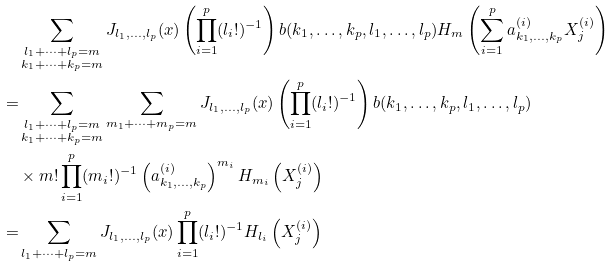<formula> <loc_0><loc_0><loc_500><loc_500>& \sum _ { \substack { l _ { 1 } + \dots + l _ { p } = m \\ k _ { 1 } + \dots + k _ { p } = m } } J _ { l _ { 1 } , \dots , l _ { p } } ( x ) \left ( \prod _ { i = 1 } ^ { p } ( l _ { i } ! ) ^ { - 1 } \right ) b ( k _ { 1 } , \dots , k _ { p } , l _ { 1 } , \dots , l _ { p } ) H _ { m } \left ( \sum _ { i = 1 } ^ { p } a _ { k _ { 1 } , \dots , k _ { p } } ^ { ( i ) } X _ { j } ^ { ( i ) } \right ) \\ = & \sum _ { \substack { l _ { 1 } + \dots + l _ { p } = m \\ k _ { 1 } + \dots + k _ { p } = m } } \sum _ { m _ { 1 } + \dots + m _ { p } = m } J _ { l _ { 1 } , \dots , l _ { p } } ( x ) \left ( \prod _ { i = 1 } ^ { p } ( l _ { i } ! ) ^ { - 1 } \right ) b ( k _ { 1 } , \dots , k _ { p } , l _ { 1 } , \dots , l _ { p } ) \\ & \times m ! \prod _ { i = 1 } ^ { p } ( m _ { i } ! ) ^ { - 1 } \left ( a _ { k _ { 1 } , \dots , k _ { p } } ^ { ( i ) } \right ) ^ { m _ { i } } H _ { m _ { i } } \left ( X _ { j } ^ { ( i ) } \right ) \\ = & \sum _ { l _ { 1 } + \dots + l _ { p } = m } J _ { l _ { 1 } , \dots , l _ { p } } ( x ) \prod _ { i = 1 } ^ { p } ( l _ { i } ! ) ^ { - 1 } H _ { l _ { i } } \left ( X _ { j } ^ { ( i ) } \right )</formula> 